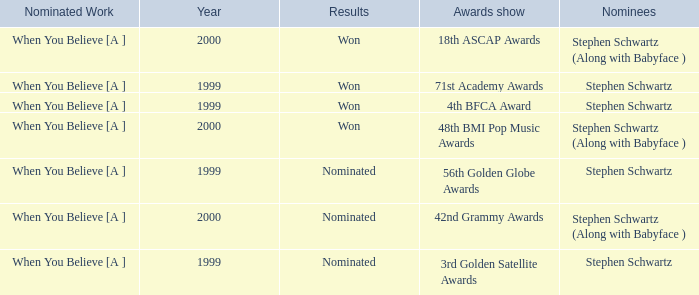Which Nominated Work won in 2000? When You Believe [A ], When You Believe [A ]. 